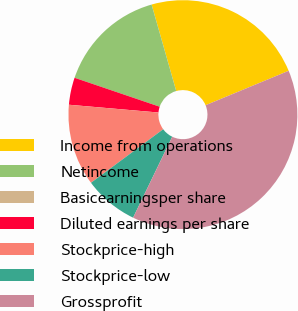<chart> <loc_0><loc_0><loc_500><loc_500><pie_chart><fcel>Income from operations<fcel>Netincome<fcel>Basicearningsper share<fcel>Diluted earnings per share<fcel>Stockprice-high<fcel>Stockprice-low<fcel>Grossprofit<nl><fcel>23.16%<fcel>15.37%<fcel>0.0%<fcel>3.84%<fcel>11.53%<fcel>7.68%<fcel>38.42%<nl></chart> 